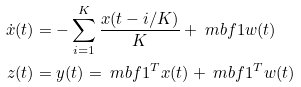Convert formula to latex. <formula><loc_0><loc_0><loc_500><loc_500>\dot { x } ( t ) & = - \sum _ { i = 1 } ^ { K } \frac { x ( t - i / K ) } { K } + \ m b f 1 w ( t ) \\ z ( t ) & = y ( t ) = \ m b f 1 ^ { T } x ( t ) + \ m b f 1 ^ { T } w ( t )</formula> 